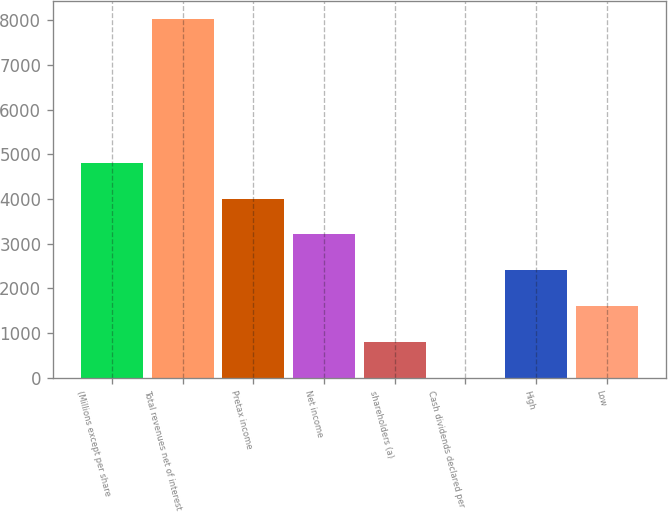Convert chart. <chart><loc_0><loc_0><loc_500><loc_500><bar_chart><fcel>(Millions except per share<fcel>Total revenues net of interest<fcel>Pretax income<fcel>Net income<fcel>shareholders (a)<fcel>Cash dividends declared per<fcel>High<fcel>Low<nl><fcel>4813.34<fcel>8022<fcel>4011.17<fcel>3209<fcel>802.49<fcel>0.32<fcel>2406.83<fcel>1604.66<nl></chart> 